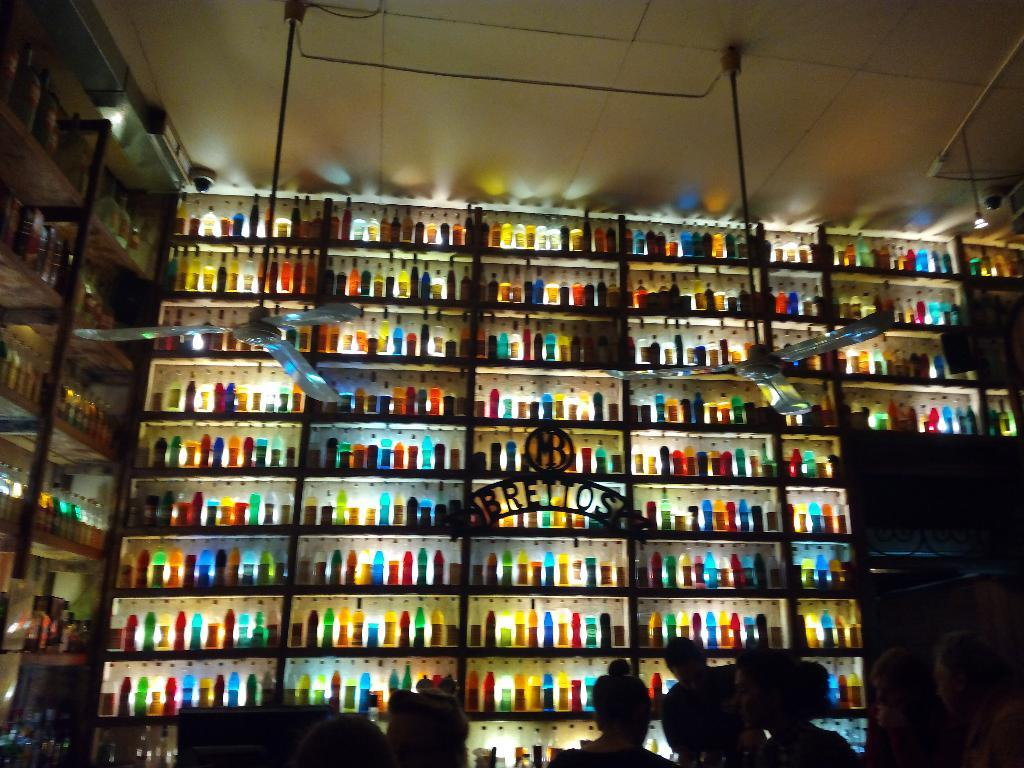What can be seen arranged in racks in the image? There are bottles arranged in racks in the image. Who or what is present at the bottom of the image? There are people at the bottom of the image. What type of cooling device is hanged from the roof in the image? Fans are hanged from the roof in the image. What type of appliance can be seen in the market in the image? There is no market or appliance present in the image. What kind of cakes are being sold by the people in the image? There is no mention of cakes or any food items being sold in the image. 